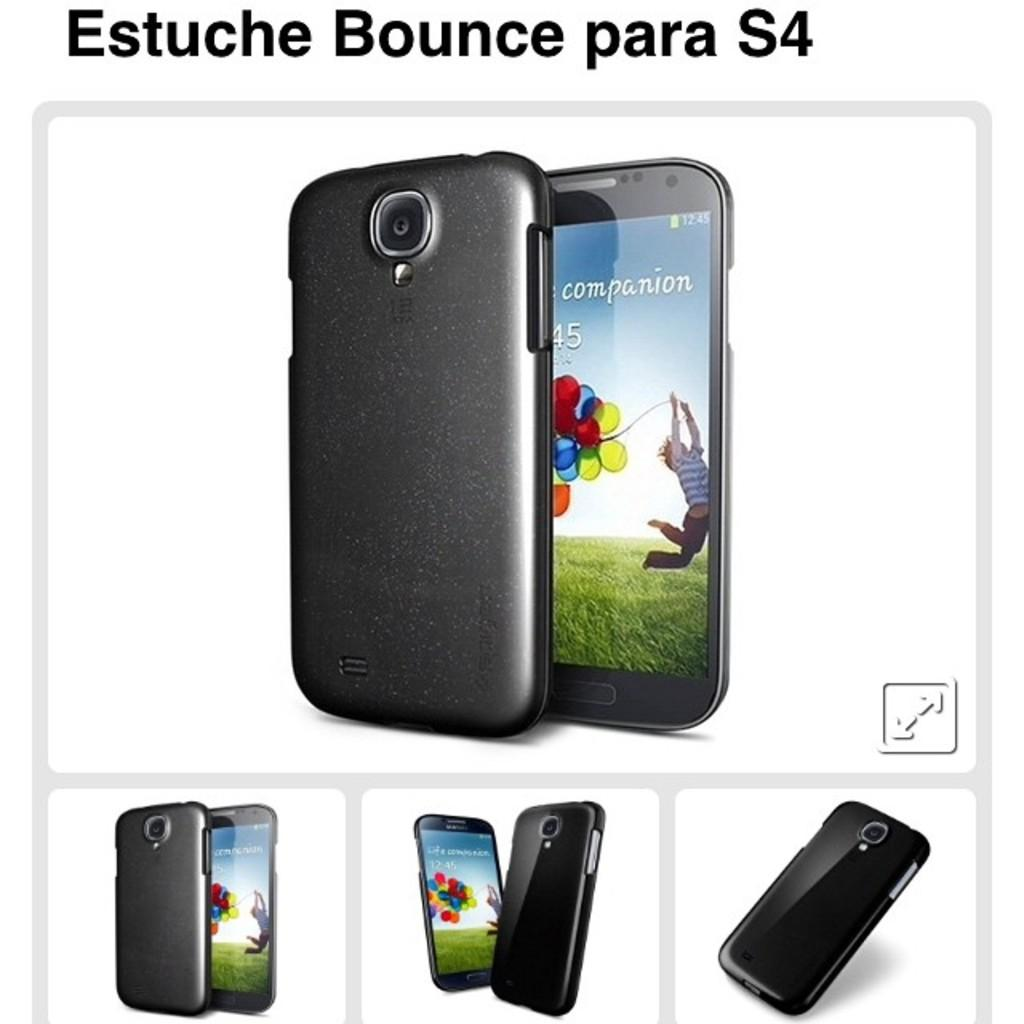What is the main subject of the poster in the image? The poster contains images of mobiles. Is there any text on the poster? Yes, there is text at the top of the poster. Where is the store located in the image? There is no store present in the image. Can you see anyone kicking a crate in the image? There is no one kicking a crate in the image. 